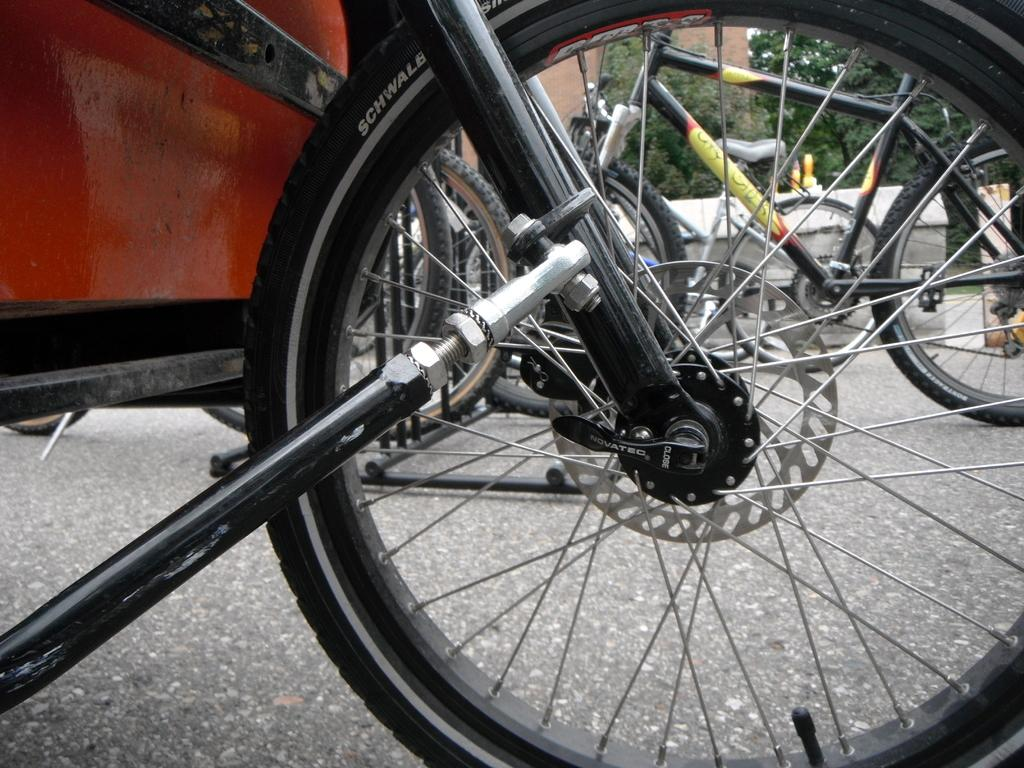What type of vehicles are on the road in the image? There are bicycles on the road in the image. What can be seen in the background of the image? There are trees and a building in the background of the image. What committee is responsible for maintaining the road in the image? There is no committee mentioned or implied in the image, as it only shows bicycles on the road and trees and a building in the background. 